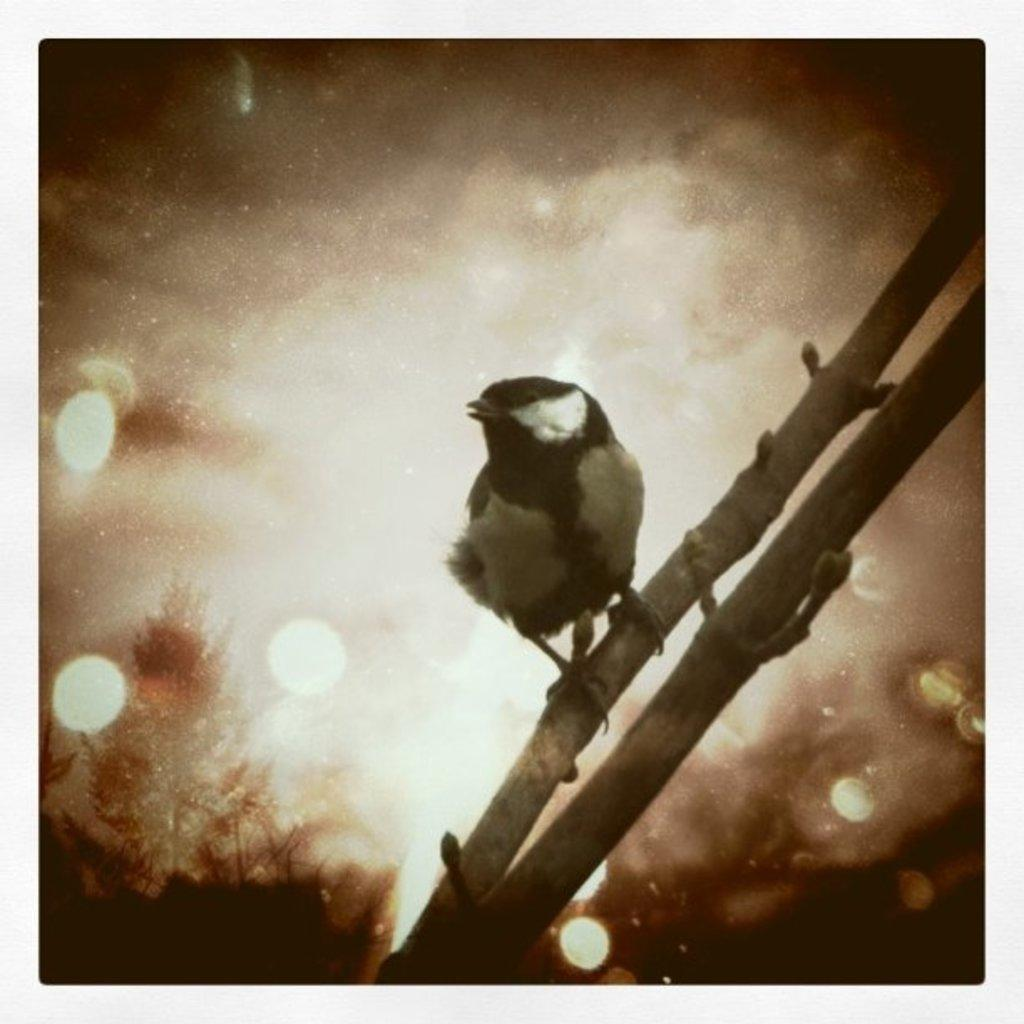What can be observed about the image's appearance? The image appears to be edited. What type of animal is present in the image? There is a bird in the image. Can you describe the bird's coloring? The bird has white, grey, and black coloring. Where is the bird located in the image? The bird is on a stem. Are there any other stems visible in the image? Yes, there is another stem visible in the image. What grade did the bird receive for its performance in the image? There is no indication of a performance or grading system in the image, as it features a bird on a stem. 